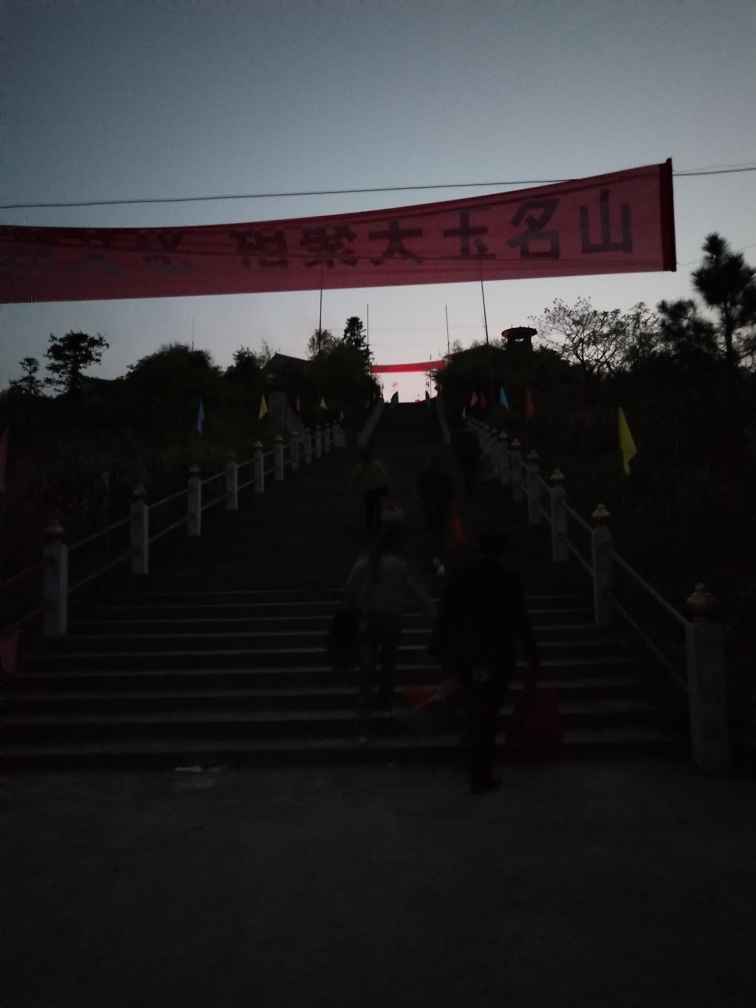Is there any identifiable text or symbols in the image? There is a large banner in the image with text that appears to be non-Latin characters, perhaps Chinese. Due to the quality of the image, it is difficult to discern the exact characters or their meaning. However, such banners commonly display messages related to events or slogans associated with an event or location. 